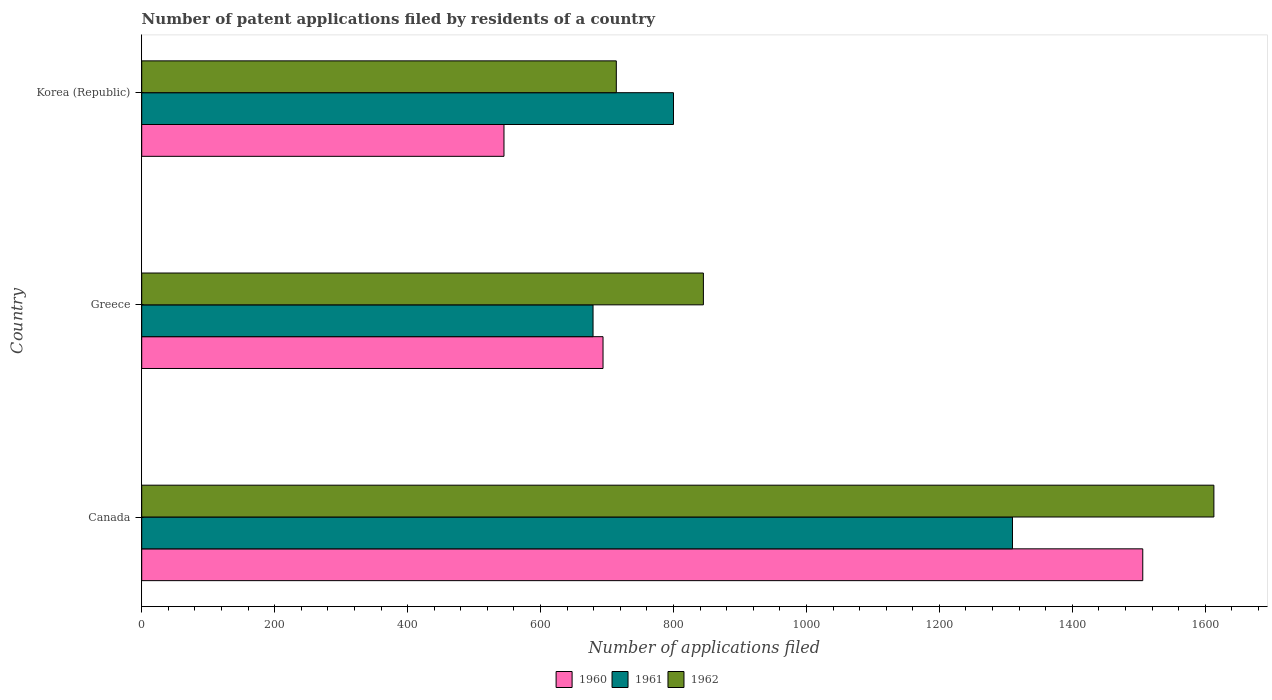Are the number of bars per tick equal to the number of legend labels?
Offer a terse response. Yes. Are the number of bars on each tick of the Y-axis equal?
Your answer should be compact. Yes. How many bars are there on the 1st tick from the top?
Your answer should be compact. 3. What is the label of the 1st group of bars from the top?
Your answer should be very brief. Korea (Republic). What is the number of applications filed in 1961 in Korea (Republic)?
Ensure brevity in your answer.  800. Across all countries, what is the maximum number of applications filed in 1960?
Offer a terse response. 1506. Across all countries, what is the minimum number of applications filed in 1962?
Ensure brevity in your answer.  714. In which country was the number of applications filed in 1961 maximum?
Your answer should be very brief. Canada. In which country was the number of applications filed in 1960 minimum?
Your answer should be compact. Korea (Republic). What is the total number of applications filed in 1960 in the graph?
Ensure brevity in your answer.  2745. What is the difference between the number of applications filed in 1961 in Greece and that in Korea (Republic)?
Keep it short and to the point. -121. What is the difference between the number of applications filed in 1960 in Greece and the number of applications filed in 1962 in Canada?
Make the answer very short. -919. What is the average number of applications filed in 1960 per country?
Your answer should be very brief. 915. What is the difference between the number of applications filed in 1960 and number of applications filed in 1962 in Canada?
Keep it short and to the point. -107. In how many countries, is the number of applications filed in 1962 greater than 800 ?
Keep it short and to the point. 2. What is the ratio of the number of applications filed in 1962 in Canada to that in Korea (Republic)?
Provide a succinct answer. 2.26. Is the number of applications filed in 1960 in Greece less than that in Korea (Republic)?
Provide a succinct answer. No. What is the difference between the highest and the second highest number of applications filed in 1961?
Make the answer very short. 510. What is the difference between the highest and the lowest number of applications filed in 1962?
Offer a very short reply. 899. Is the sum of the number of applications filed in 1962 in Canada and Korea (Republic) greater than the maximum number of applications filed in 1960 across all countries?
Offer a very short reply. Yes. What does the 3rd bar from the top in Canada represents?
Your answer should be compact. 1960. Are all the bars in the graph horizontal?
Offer a very short reply. Yes. What is the difference between two consecutive major ticks on the X-axis?
Your answer should be compact. 200. How many legend labels are there?
Ensure brevity in your answer.  3. How are the legend labels stacked?
Your answer should be compact. Horizontal. What is the title of the graph?
Keep it short and to the point. Number of patent applications filed by residents of a country. What is the label or title of the X-axis?
Your response must be concise. Number of applications filed. What is the Number of applications filed in 1960 in Canada?
Make the answer very short. 1506. What is the Number of applications filed of 1961 in Canada?
Your answer should be very brief. 1310. What is the Number of applications filed of 1962 in Canada?
Your answer should be very brief. 1613. What is the Number of applications filed of 1960 in Greece?
Your answer should be very brief. 694. What is the Number of applications filed of 1961 in Greece?
Offer a very short reply. 679. What is the Number of applications filed of 1962 in Greece?
Your answer should be very brief. 845. What is the Number of applications filed of 1960 in Korea (Republic)?
Keep it short and to the point. 545. What is the Number of applications filed in 1961 in Korea (Republic)?
Provide a short and direct response. 800. What is the Number of applications filed in 1962 in Korea (Republic)?
Keep it short and to the point. 714. Across all countries, what is the maximum Number of applications filed of 1960?
Provide a short and direct response. 1506. Across all countries, what is the maximum Number of applications filed of 1961?
Provide a succinct answer. 1310. Across all countries, what is the maximum Number of applications filed in 1962?
Provide a short and direct response. 1613. Across all countries, what is the minimum Number of applications filed in 1960?
Your answer should be very brief. 545. Across all countries, what is the minimum Number of applications filed of 1961?
Your response must be concise. 679. Across all countries, what is the minimum Number of applications filed of 1962?
Offer a very short reply. 714. What is the total Number of applications filed in 1960 in the graph?
Provide a succinct answer. 2745. What is the total Number of applications filed of 1961 in the graph?
Offer a terse response. 2789. What is the total Number of applications filed in 1962 in the graph?
Keep it short and to the point. 3172. What is the difference between the Number of applications filed in 1960 in Canada and that in Greece?
Offer a very short reply. 812. What is the difference between the Number of applications filed of 1961 in Canada and that in Greece?
Offer a terse response. 631. What is the difference between the Number of applications filed of 1962 in Canada and that in Greece?
Provide a short and direct response. 768. What is the difference between the Number of applications filed in 1960 in Canada and that in Korea (Republic)?
Offer a terse response. 961. What is the difference between the Number of applications filed of 1961 in Canada and that in Korea (Republic)?
Your response must be concise. 510. What is the difference between the Number of applications filed in 1962 in Canada and that in Korea (Republic)?
Make the answer very short. 899. What is the difference between the Number of applications filed in 1960 in Greece and that in Korea (Republic)?
Provide a succinct answer. 149. What is the difference between the Number of applications filed in 1961 in Greece and that in Korea (Republic)?
Your response must be concise. -121. What is the difference between the Number of applications filed of 1962 in Greece and that in Korea (Republic)?
Your answer should be compact. 131. What is the difference between the Number of applications filed of 1960 in Canada and the Number of applications filed of 1961 in Greece?
Offer a terse response. 827. What is the difference between the Number of applications filed of 1960 in Canada and the Number of applications filed of 1962 in Greece?
Provide a succinct answer. 661. What is the difference between the Number of applications filed in 1961 in Canada and the Number of applications filed in 1962 in Greece?
Provide a short and direct response. 465. What is the difference between the Number of applications filed of 1960 in Canada and the Number of applications filed of 1961 in Korea (Republic)?
Give a very brief answer. 706. What is the difference between the Number of applications filed in 1960 in Canada and the Number of applications filed in 1962 in Korea (Republic)?
Provide a succinct answer. 792. What is the difference between the Number of applications filed of 1961 in Canada and the Number of applications filed of 1962 in Korea (Republic)?
Offer a terse response. 596. What is the difference between the Number of applications filed in 1960 in Greece and the Number of applications filed in 1961 in Korea (Republic)?
Provide a succinct answer. -106. What is the difference between the Number of applications filed of 1960 in Greece and the Number of applications filed of 1962 in Korea (Republic)?
Keep it short and to the point. -20. What is the difference between the Number of applications filed in 1961 in Greece and the Number of applications filed in 1962 in Korea (Republic)?
Your answer should be very brief. -35. What is the average Number of applications filed in 1960 per country?
Your response must be concise. 915. What is the average Number of applications filed of 1961 per country?
Your answer should be very brief. 929.67. What is the average Number of applications filed in 1962 per country?
Your answer should be very brief. 1057.33. What is the difference between the Number of applications filed in 1960 and Number of applications filed in 1961 in Canada?
Make the answer very short. 196. What is the difference between the Number of applications filed in 1960 and Number of applications filed in 1962 in Canada?
Your answer should be very brief. -107. What is the difference between the Number of applications filed in 1961 and Number of applications filed in 1962 in Canada?
Offer a terse response. -303. What is the difference between the Number of applications filed of 1960 and Number of applications filed of 1961 in Greece?
Offer a very short reply. 15. What is the difference between the Number of applications filed of 1960 and Number of applications filed of 1962 in Greece?
Provide a succinct answer. -151. What is the difference between the Number of applications filed in 1961 and Number of applications filed in 1962 in Greece?
Provide a succinct answer. -166. What is the difference between the Number of applications filed of 1960 and Number of applications filed of 1961 in Korea (Republic)?
Ensure brevity in your answer.  -255. What is the difference between the Number of applications filed of 1960 and Number of applications filed of 1962 in Korea (Republic)?
Make the answer very short. -169. What is the difference between the Number of applications filed of 1961 and Number of applications filed of 1962 in Korea (Republic)?
Your answer should be compact. 86. What is the ratio of the Number of applications filed in 1960 in Canada to that in Greece?
Your response must be concise. 2.17. What is the ratio of the Number of applications filed in 1961 in Canada to that in Greece?
Your answer should be very brief. 1.93. What is the ratio of the Number of applications filed in 1962 in Canada to that in Greece?
Offer a terse response. 1.91. What is the ratio of the Number of applications filed in 1960 in Canada to that in Korea (Republic)?
Your response must be concise. 2.76. What is the ratio of the Number of applications filed in 1961 in Canada to that in Korea (Republic)?
Offer a very short reply. 1.64. What is the ratio of the Number of applications filed of 1962 in Canada to that in Korea (Republic)?
Your answer should be very brief. 2.26. What is the ratio of the Number of applications filed in 1960 in Greece to that in Korea (Republic)?
Offer a very short reply. 1.27. What is the ratio of the Number of applications filed of 1961 in Greece to that in Korea (Republic)?
Offer a very short reply. 0.85. What is the ratio of the Number of applications filed in 1962 in Greece to that in Korea (Republic)?
Your answer should be very brief. 1.18. What is the difference between the highest and the second highest Number of applications filed in 1960?
Make the answer very short. 812. What is the difference between the highest and the second highest Number of applications filed in 1961?
Make the answer very short. 510. What is the difference between the highest and the second highest Number of applications filed of 1962?
Make the answer very short. 768. What is the difference between the highest and the lowest Number of applications filed of 1960?
Keep it short and to the point. 961. What is the difference between the highest and the lowest Number of applications filed in 1961?
Give a very brief answer. 631. What is the difference between the highest and the lowest Number of applications filed in 1962?
Provide a succinct answer. 899. 